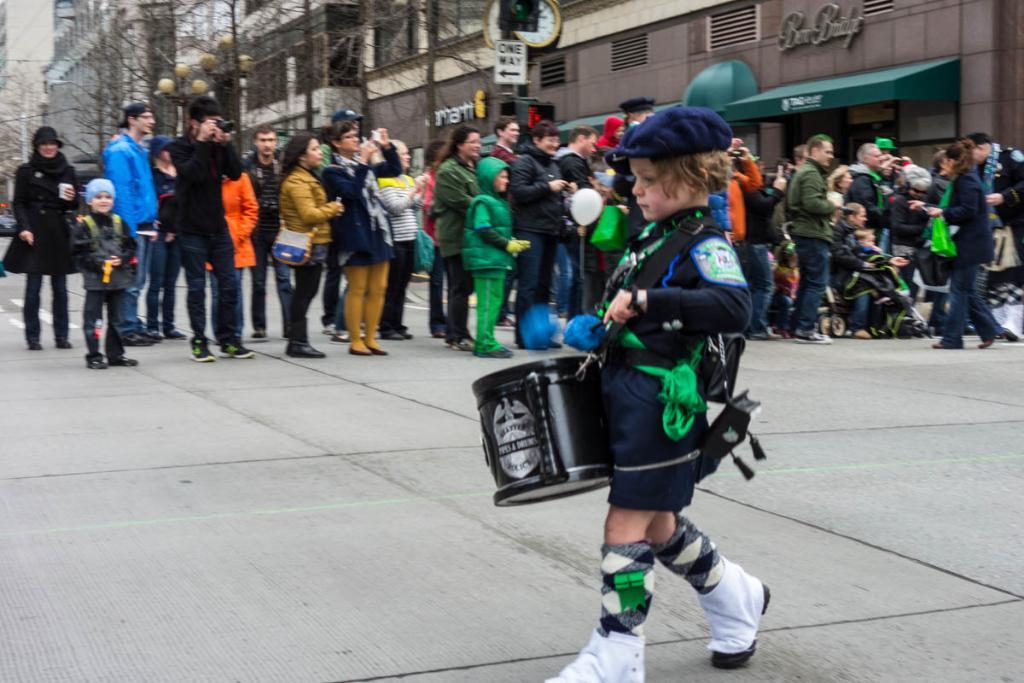How would you summarize this image in a sentence or two? In the image we can see there are people standing and some of them are walking, they are wearing clothes, shoes and some of them are wearing a cap and holding and an object in hand. Here we can see a child holding a musical instrument. Here we can see the road, trees, light poles, the clock and the building. 